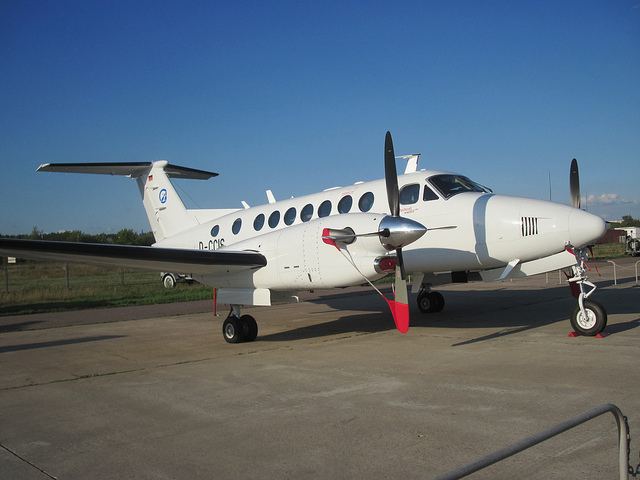Please extract the text content from this image. O.CCIS 